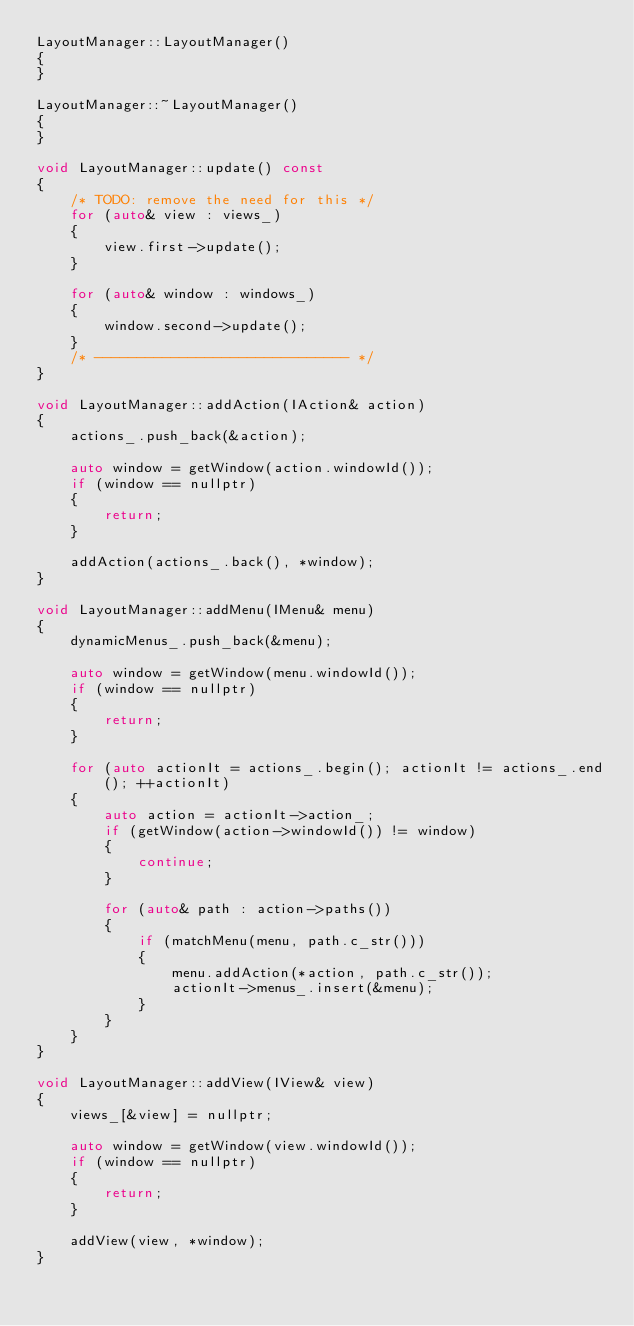Convert code to text. <code><loc_0><loc_0><loc_500><loc_500><_C++_>LayoutManager::LayoutManager()
{
}

LayoutManager::~LayoutManager()
{
}

void LayoutManager::update() const
{
	/* TODO: remove the need for this */
	for (auto& view : views_)
	{
		view.first->update();
	}

	for (auto& window : windows_)
	{
		window.second->update();
	}
	/* ------------------------------ */
}

void LayoutManager::addAction(IAction& action)
{
	actions_.push_back(&action);

	auto window = getWindow(action.windowId());
	if (window == nullptr)
	{
		return;
	}

	addAction(actions_.back(), *window);
}

void LayoutManager::addMenu(IMenu& menu)
{
	dynamicMenus_.push_back(&menu);

	auto window = getWindow(menu.windowId());
	if (window == nullptr)
	{
		return;
	}

	for (auto actionIt = actions_.begin(); actionIt != actions_.end(); ++actionIt)
	{
		auto action = actionIt->action_;
		if (getWindow(action->windowId()) != window)
		{
			continue;
		}

		for (auto& path : action->paths())
		{
			if (matchMenu(menu, path.c_str()))
			{
				menu.addAction(*action, path.c_str());
				actionIt->menus_.insert(&menu);
			}
		}
	}
}

void LayoutManager::addView(IView& view)
{
	views_[&view] = nullptr;

	auto window = getWindow(view.windowId());
	if (window == nullptr)
	{
		return;
	}

	addView(view, *window);
}
</code> 